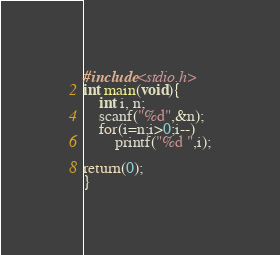Convert code to text. <code><loc_0><loc_0><loc_500><loc_500><_C_>#include<stdio.h>
int main(void){
	int i, n;
	scanf("%d",&n);
	for(i=n;i>0;i--)
		printf("%d ",i);

return(0);
}

</code> 